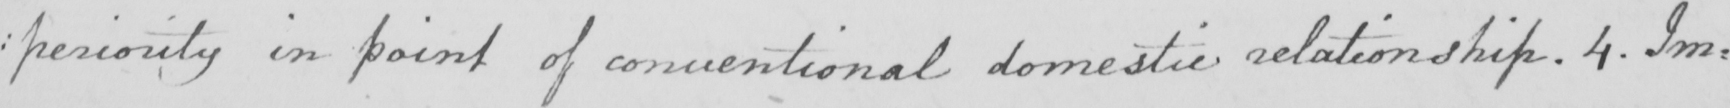What does this handwritten line say? : periority in point of conventional domestic relationship . 4 . Im : 